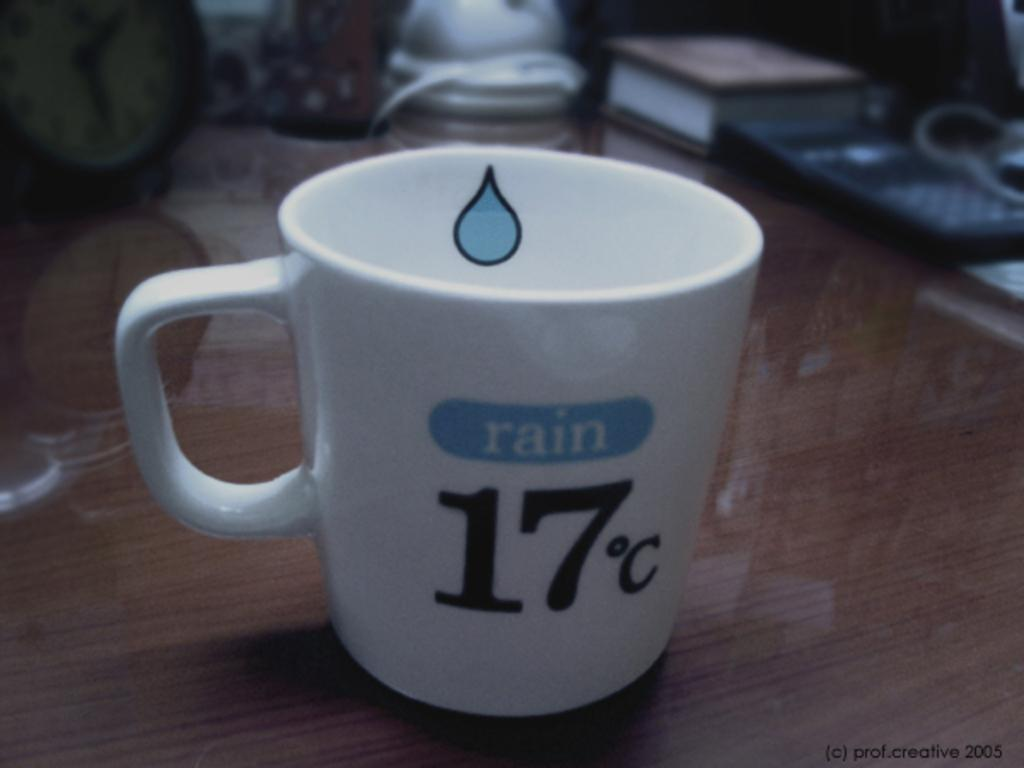<image>
Present a compact description of the photo's key features. A white mug with the weather forecast of rain on it sits on a wooden desk. 